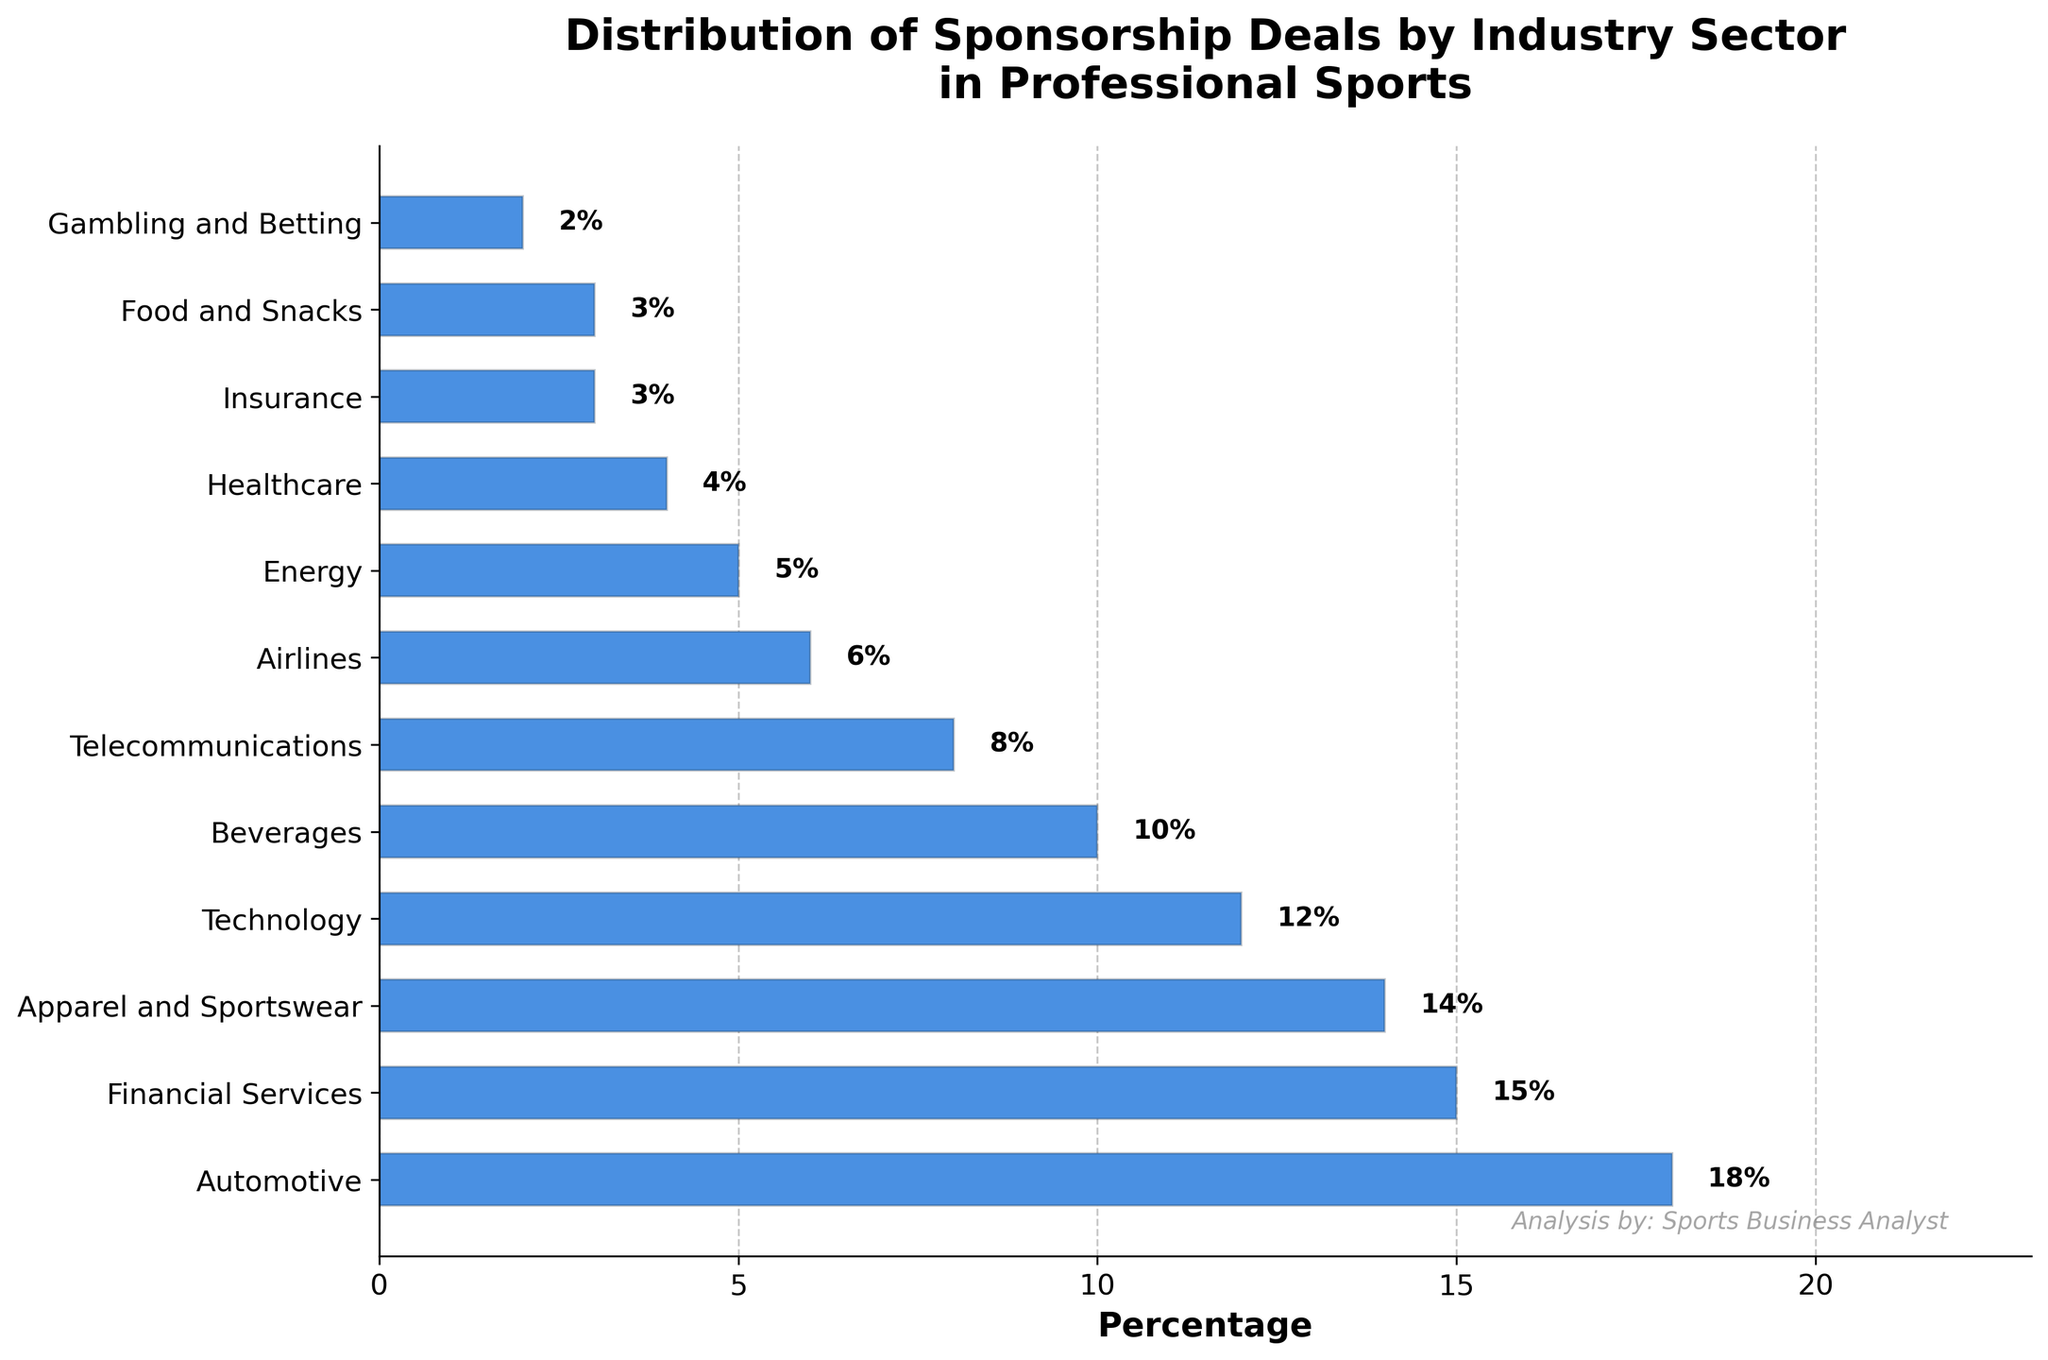What is the least represented industry in the distribution of sponsorship deals? The bar chart shows that the smallest percentage value is for Gambling and Betting, which is 2%.
Answer: Gambling and Betting Which industry has the highest percentage of sponsorship deals? The tallest bar in the chart indicates the Automotive industry, which has the highest percentage of 18%.
Answer: Automotive How much more percentage does the Automotive industry have compared to the Telecommunications industry? The percentage of the Automotive industry is 18%, and the Telecommunications industry is 8%. The difference is 18% - 8% = 10%.
Answer: 10% What is the combined percentage of sponsorship deals for Apparel and Sportswear and Beverages industries? The percentage for Apparel and Sportswear is 14% and for Beverages is 10%. The combined percentage is 14% + 10% = 24%.
Answer: 24% Which industries have exactly 3% of the sponsorship deals each? The chart indicates that both Insurance and Food and Snacks have bars labeled with 3%.
Answer: Insurance and Food and Snacks What percentage of sponsorship deals is represented by Healthcare? The bar labeled Healthcare has a percentage of 4%.
Answer: 4% What is the difference between the percentage of Financial Services and Technology sponsorship deals? The Financial Services industry has 15% and Technology has 12%. The difference is 15% - 12% = 3%.
Answer: 3% How many industries have a percentage of sponsorship deals that is below 5%? The industries with percentages below 5% are Healthcare, Insurance, Food and Snacks, and Gambling and Betting. There are 4 industries in total.
Answer: 4 Which industry has a higher percentage of sponsorship deals, Airlines or Energy? The chart shows that Airlines have 6% and Energy has 5%. Airlines have a higher percentage.
Answer: Airlines What is the total percentage of sponsorship deals in industries related to transportation (Automotive, Airlines)? Automotives have 18% and Airlines have 6%. The total is 18% + 6% = 24%.
Answer: 24% 